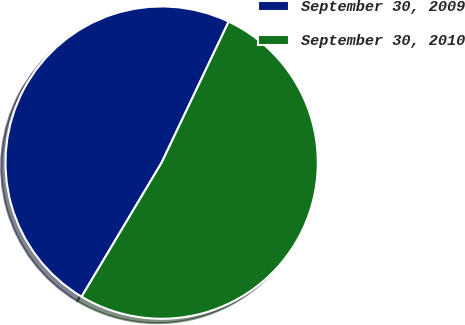Convert chart. <chart><loc_0><loc_0><loc_500><loc_500><pie_chart><fcel>September 30, 2009<fcel>September 30, 2010<nl><fcel>48.5%<fcel>51.5%<nl></chart> 